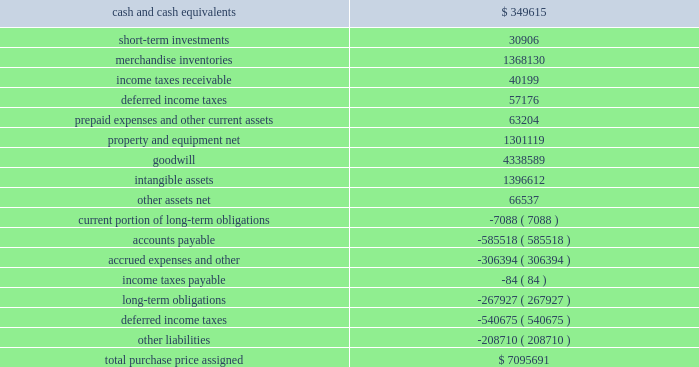Dollar general corporation and subsidiaries notes to consolidated financial statements ( continued ) 3 .
Merger ( continued ) merger as a subsidiary of buck .
The company 2019s results of operations after july 6 , 2007 include the effects of the merger .
The aggregate purchase price was approximately $ 7.1 billion , including direct costs of the merger , and was funded primarily through debt financings as described more fully below in note 7 and cash equity contributions from kkr , gs capital partners vi fund , l.p .
And affiliated funds ( affiliates of goldman , sachs & co. ) , and other equity co-investors ( collectively , the 2018 2018investors 2019 2019 of approximately $ 2.8 billion ( 316.2 million shares of new common stock , $ 0.875 par value per share , valued at $ 8.75 per share ) .
Also in connection with the merger , certain of the company 2019s management employees invested in and were issued new shares , representing less than 1% ( 1 % ) of the outstanding shares , in the company .
Pursuant to the terms of the merger agreement , the former holders of the predecessor 2019s common stock , par value $ 0.50 per share , received $ 22.00 per share , or approximately $ 6.9 billion , and all such shares were acquired as a result of the merger .
As discussed in note 1 , the merger was accounted for as a reverse acquisition in accordance with applicable purchase accounting provisions .
Because of this accounting treatment , the company 2019s assets and liabilities have properly been accounted for at their estimated fair values as of the merger date .
The aggregate purchase price has been allocated to the tangible and intangible assets acquired and liabilities assumed based upon an assessment of their relative fair values as of the merger date .
The allocation of the purchase price is as follows ( in thousands ) : .
The purchase price allocation included approximately $ 4.34 billion of goodwill , none of which is expected to be deductible for tax purposes .
The goodwill balance at january 30 , 2009 decreased $ 6.3 million from the balance at february 1 , 2008 due to an adjustment to income tax contingencies as further discussed in note 6. .
How much of the purchase price was allocated to intangibles? 
Rationale: goodwill is also an intangible
Computations: (4338589 + 1396612)
Answer: 5735201.0. 